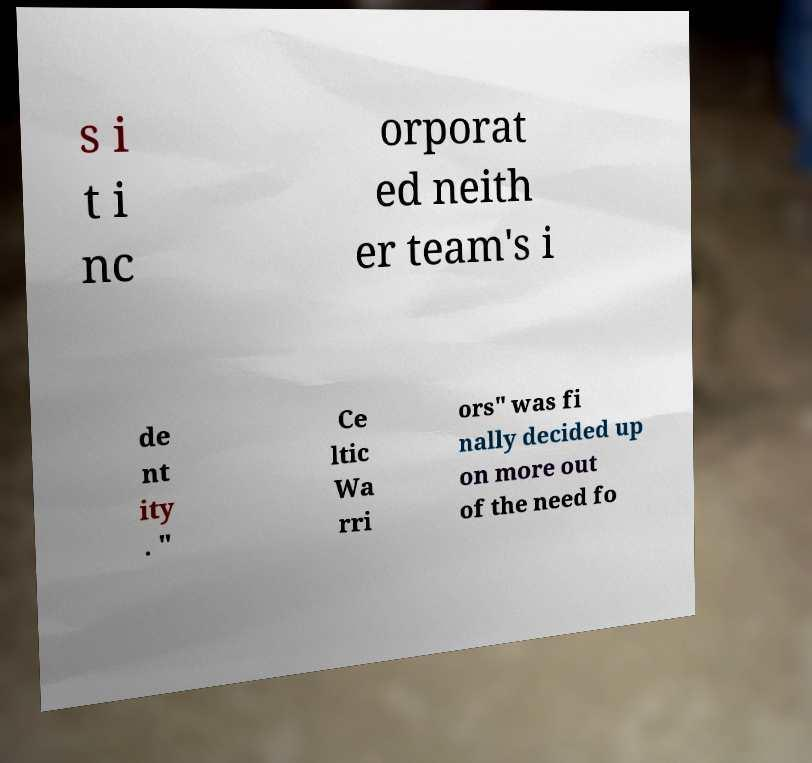For documentation purposes, I need the text within this image transcribed. Could you provide that? s i t i nc orporat ed neith er team's i de nt ity . " Ce ltic Wa rri ors" was fi nally decided up on more out of the need fo 